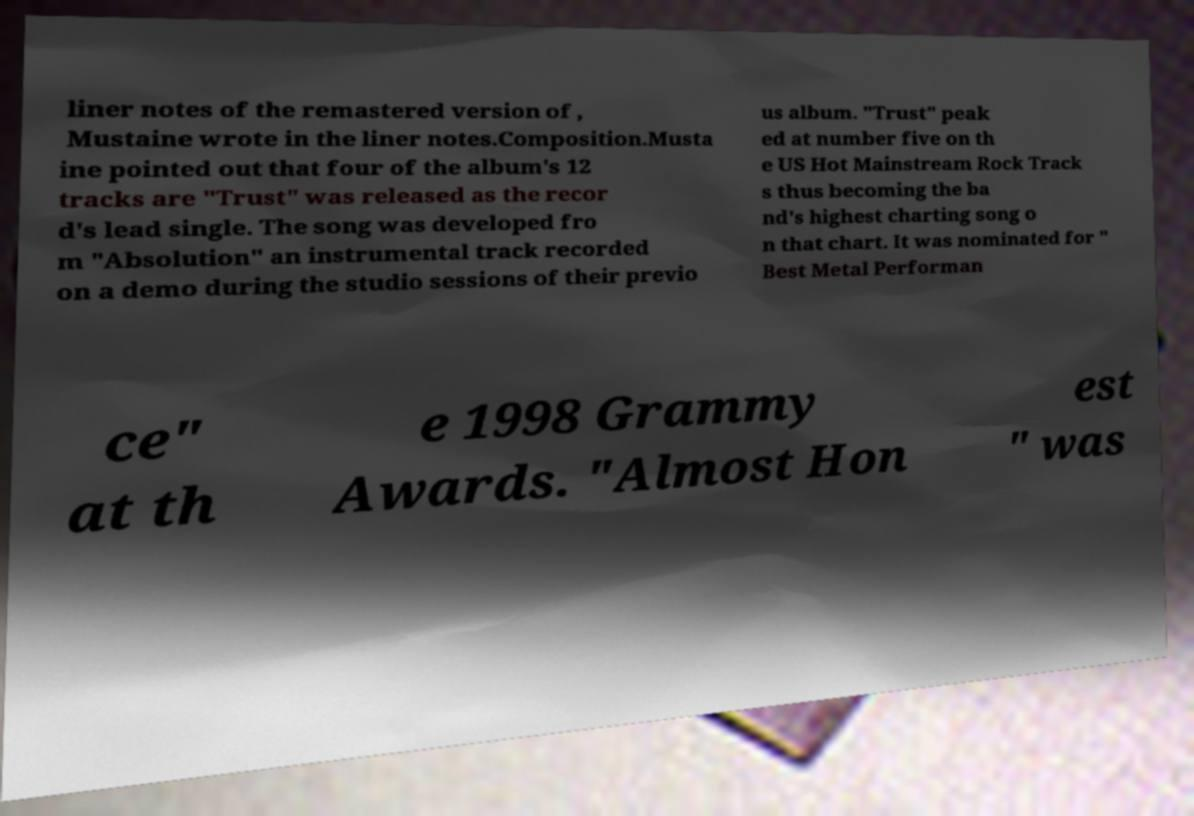For documentation purposes, I need the text within this image transcribed. Could you provide that? liner notes of the remastered version of , Mustaine wrote in the liner notes.Composition.Musta ine pointed out that four of the album's 12 tracks are "Trust" was released as the recor d's lead single. The song was developed fro m "Absolution" an instrumental track recorded on a demo during the studio sessions of their previo us album. "Trust" peak ed at number five on th e US Hot Mainstream Rock Track s thus becoming the ba nd's highest charting song o n that chart. It was nominated for " Best Metal Performan ce" at th e 1998 Grammy Awards. "Almost Hon est " was 